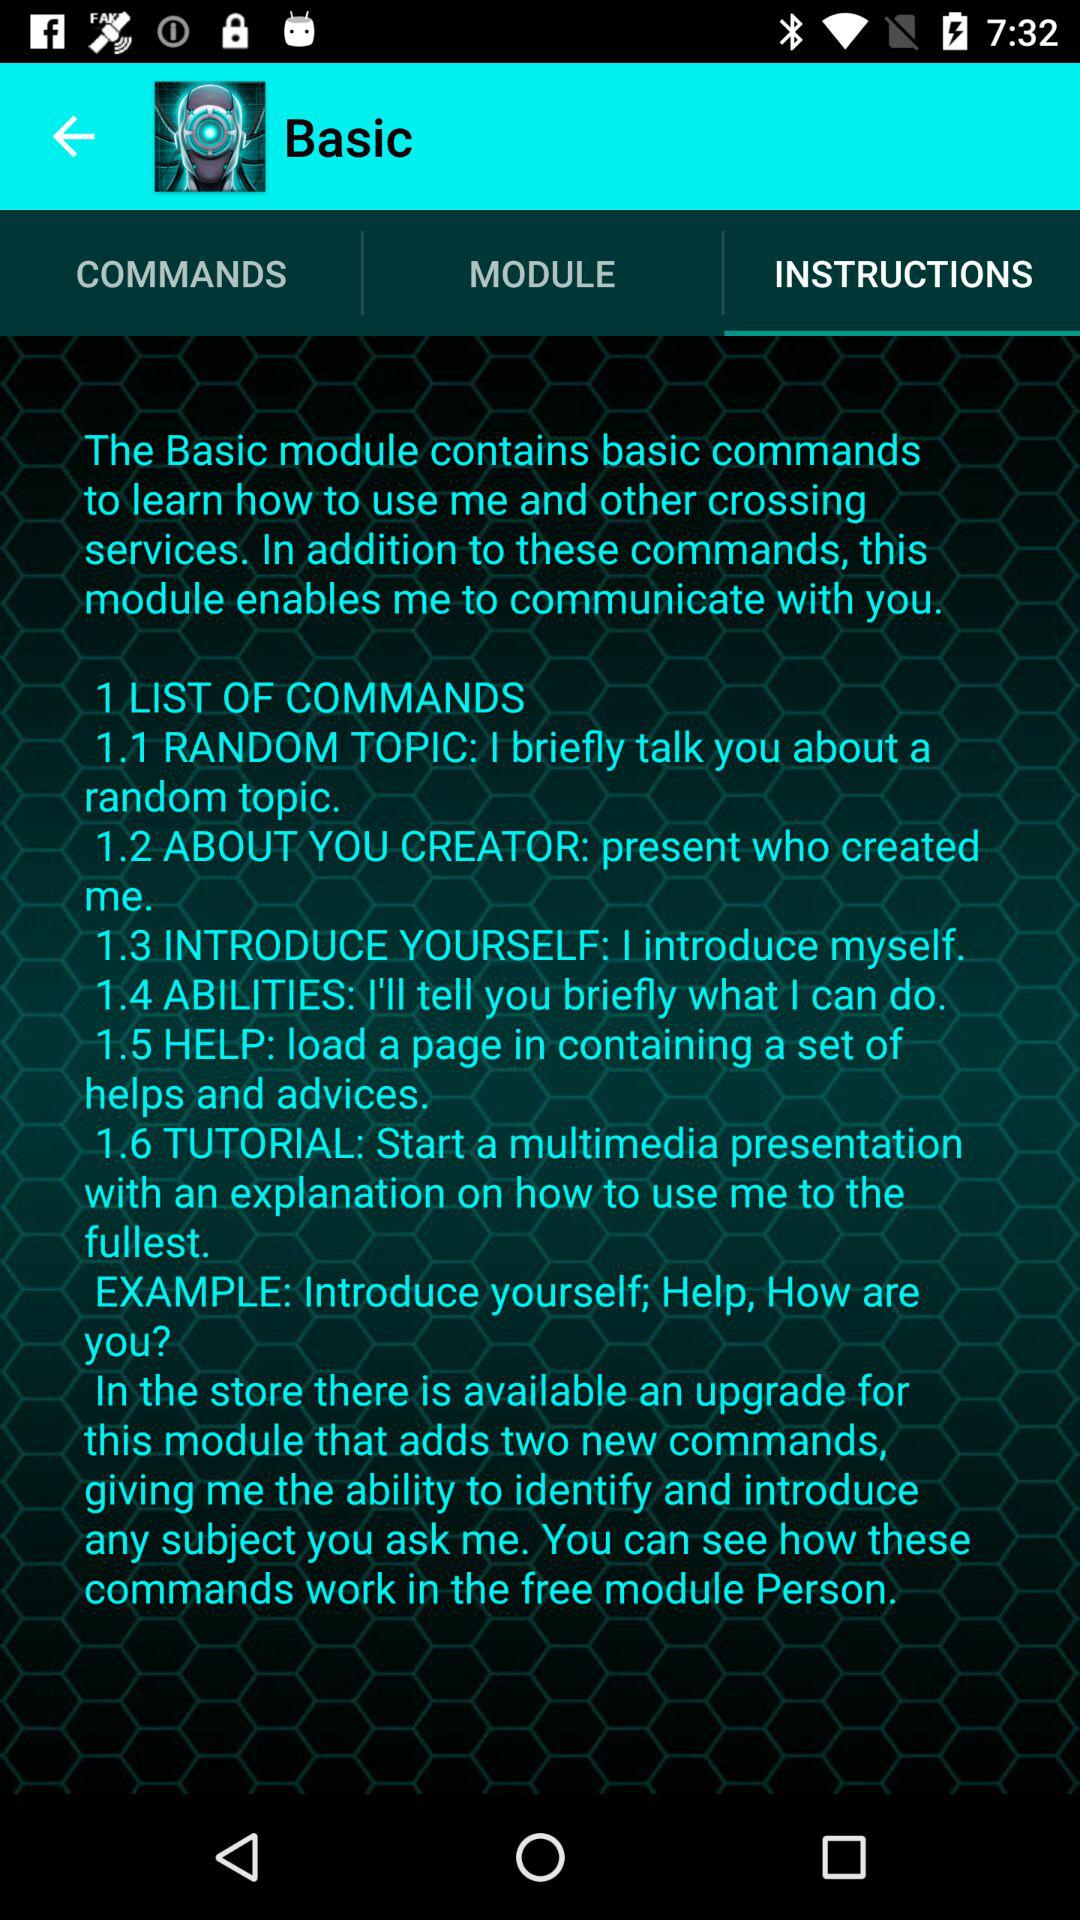How many commands are there in the Basic module?
Answer the question using a single word or phrase. 6 